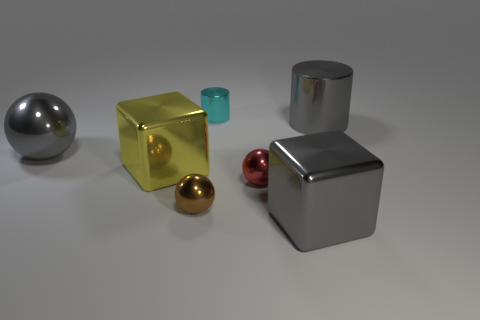What number of objects are big gray blocks in front of the large yellow metallic block or brown spheres?
Provide a succinct answer. 2. What number of gray metal objects are both behind the red metal sphere and right of the small cylinder?
Your response must be concise. 1. What number of things are either gray things in front of the small red object or metal balls behind the small brown metal sphere?
Keep it short and to the point. 3. What number of other things are the same shape as the big yellow thing?
Offer a very short reply. 1. Do the tiny metallic ball that is left of the small cyan shiny cylinder and the large metallic ball have the same color?
Your answer should be compact. No. What number of other things are there of the same size as the cyan cylinder?
Offer a very short reply. 2. Do the red sphere and the big gray cylinder have the same material?
Provide a succinct answer. Yes. What is the color of the metallic cylinder that is left of the metallic block that is in front of the tiny brown sphere?
Your answer should be very brief. Cyan. What is the size of the brown object that is the same shape as the red metal object?
Your answer should be compact. Small. Is the color of the large metal sphere the same as the large cylinder?
Keep it short and to the point. Yes. 